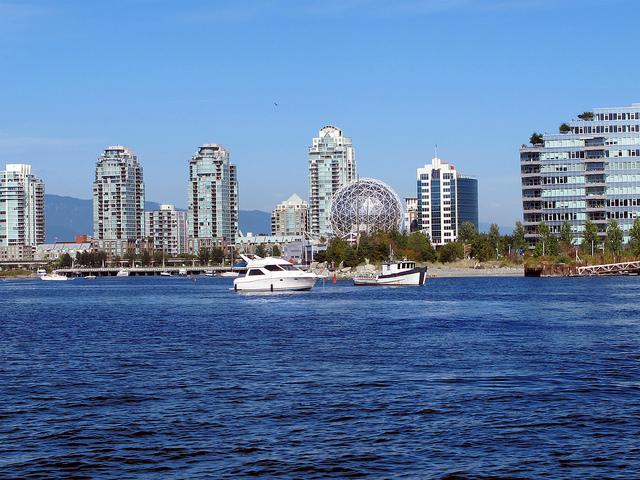Is there water?
Write a very short answer. Yes. Where is the boat?
Give a very brief answer. In water. Could this be Miami?
Write a very short answer. Yes. 